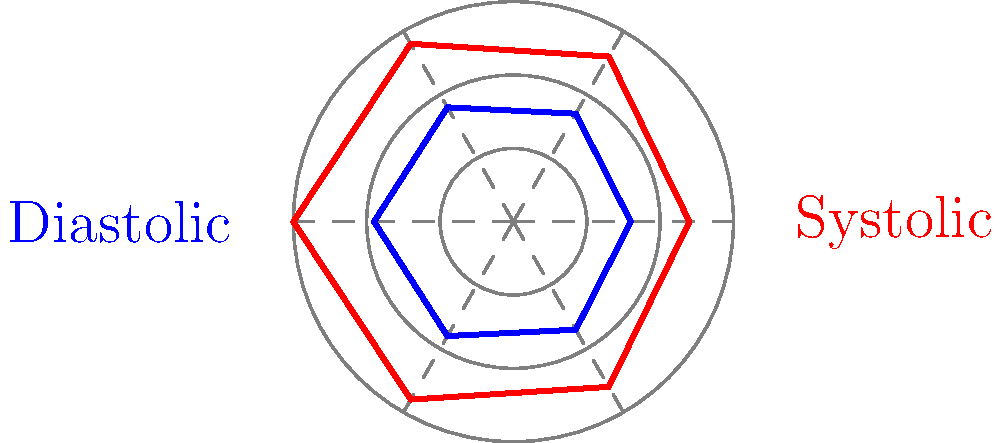In the circular blood pressure chart shown, which reading indicates the highest systolic pressure, and what is its approximate value? To determine the highest systolic pressure reading and its approximate value, we need to follow these steps:

1. Identify the systolic pressure line:
   The red line represents systolic pressure readings.

2. Locate the point furthest from the center:
   The point furthest from the center on the red line indicates the highest systolic pressure.

3. Determine the angle of this point:
   The highest point appears to be at the 180-degree mark (bottom of the circle).

4. Estimate the value:
   The chart is divided into three concentric circles, likely representing 50 mmHg intervals.
   The highest point reaches slightly beyond the second circle from the center.

5. Calculate the approximate value:
   Base value (center): 0 mmHg
   First circle: 50 mmHg
   Second circle: 100 mmHg
   The point is about halfway between the second and third circles, so we add 25 mmHg.

   Therefore, the approximate value is: 100 mmHg + 25 mmHg = 125 mmHg

6. Adjust for scale:
   Given that typical blood pressure readings are higher, we can assume the scale is likely 1.5 times larger.
   
   Final estimated value: 125 mmHg * 1.5 ≈ 150 mmHg

Thus, the highest systolic pressure reading is at the bottom of the circle (180-degree mark) and is approximately 150 mmHg.
Answer: 180 degrees, ~150 mmHg 